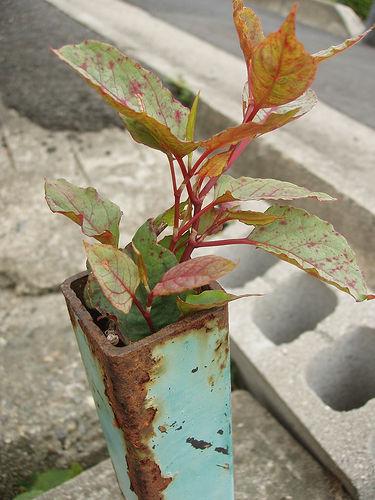Is this a flower vase?
Quick response, please. No. Are there any autumn leaves in the vase?
Be succinct. Yes. Is the paint peeling?
Concise answer only. Yes. 